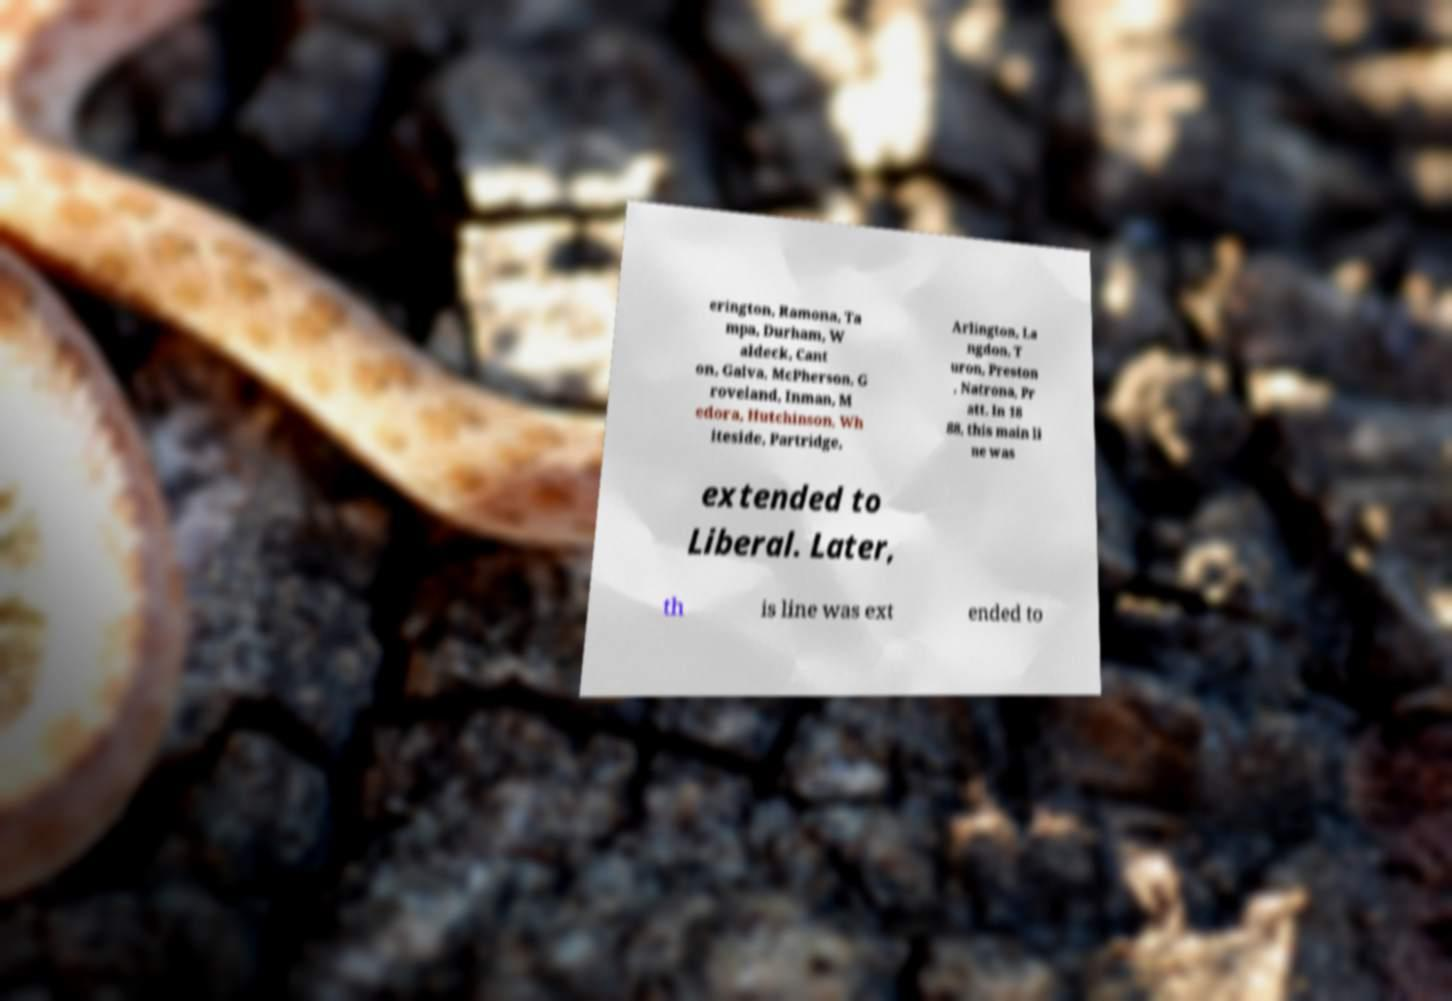I need the written content from this picture converted into text. Can you do that? erington, Ramona, Ta mpa, Durham, W aldeck, Cant on, Galva, McPherson, G roveland, Inman, M edora, Hutchinson, Wh iteside, Partridge, Arlington, La ngdon, T uron, Preston , Natrona, Pr att. In 18 88, this main li ne was extended to Liberal. Later, th is line was ext ended to 